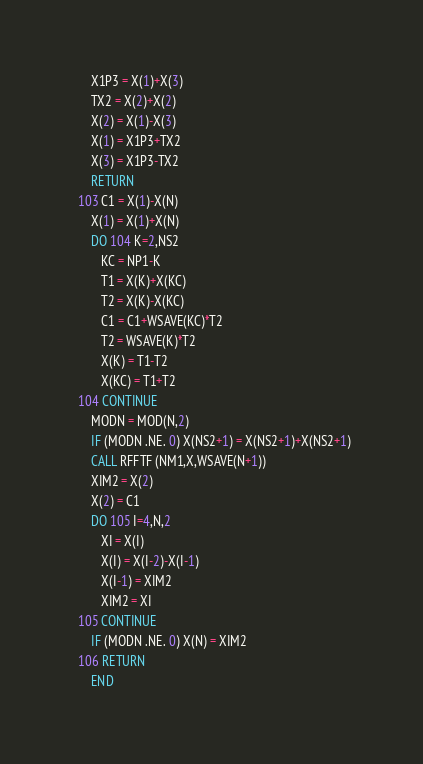Convert code to text. <code><loc_0><loc_0><loc_500><loc_500><_FORTRAN_>      X1P3 = X(1)+X(3)
      TX2 = X(2)+X(2)
      X(2) = X(1)-X(3)
      X(1) = X1P3+TX2
      X(3) = X1P3-TX2
      RETURN
  103 C1 = X(1)-X(N)
      X(1) = X(1)+X(N)
      DO 104 K=2,NS2
         KC = NP1-K
         T1 = X(K)+X(KC)
         T2 = X(K)-X(KC)
         C1 = C1+WSAVE(KC)*T2
         T2 = WSAVE(K)*T2
         X(K) = T1-T2
         X(KC) = T1+T2
  104 CONTINUE
      MODN = MOD(N,2)
      IF (MODN .NE. 0) X(NS2+1) = X(NS2+1)+X(NS2+1)
      CALL RFFTF (NM1,X,WSAVE(N+1))
      XIM2 = X(2)
      X(2) = C1
      DO 105 I=4,N,2
         XI = X(I)
         X(I) = X(I-2)-X(I-1)
         X(I-1) = XIM2
         XIM2 = XI
  105 CONTINUE
      IF (MODN .NE. 0) X(N) = XIM2
  106 RETURN
      END
</code> 